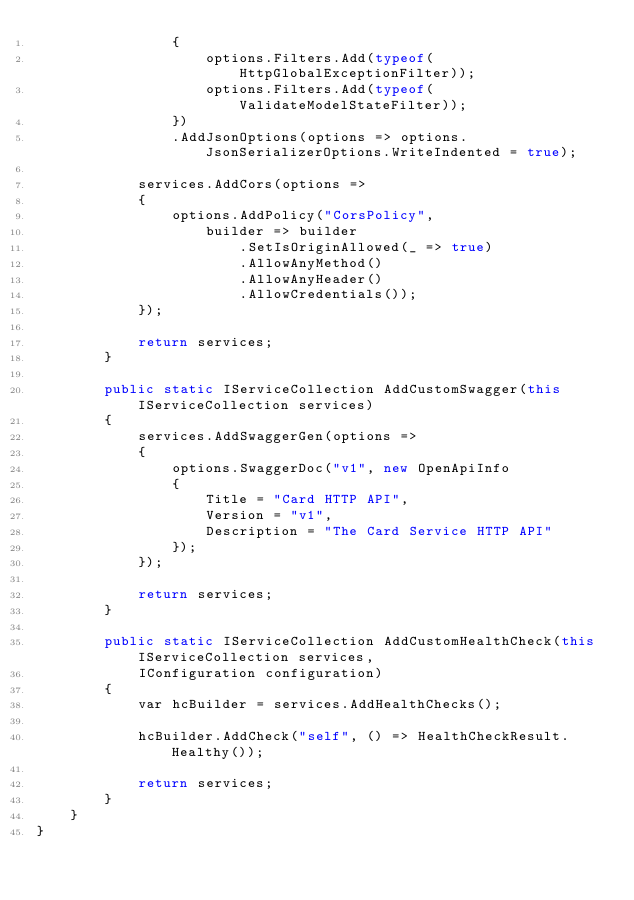Convert code to text. <code><loc_0><loc_0><loc_500><loc_500><_C#_>                {
                    options.Filters.Add(typeof(HttpGlobalExceptionFilter));
                    options.Filters.Add(typeof(ValidateModelStateFilter));
                })
                .AddJsonOptions(options => options.JsonSerializerOptions.WriteIndented = true);

            services.AddCors(options =>
            {
                options.AddPolicy("CorsPolicy",
                    builder => builder
                        .SetIsOriginAllowed(_ => true)
                        .AllowAnyMethod()
                        .AllowAnyHeader()
                        .AllowCredentials());
            });

            return services;
        }

        public static IServiceCollection AddCustomSwagger(this IServiceCollection services)
        {
            services.AddSwaggerGen(options =>
            {
                options.SwaggerDoc("v1", new OpenApiInfo
                {
                    Title = "Card HTTP API",
                    Version = "v1",
                    Description = "The Card Service HTTP API"
                });
            });

            return services;
        }

        public static IServiceCollection AddCustomHealthCheck(this IServiceCollection services,
            IConfiguration configuration)
        {
            var hcBuilder = services.AddHealthChecks();

            hcBuilder.AddCheck("self", () => HealthCheckResult.Healthy());

            return services;
        }
    }
}
</code> 